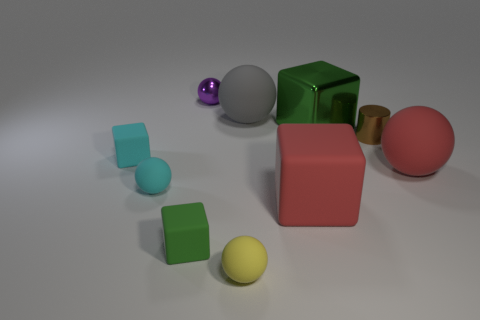Subtract all cyan blocks. How many blocks are left? 3 Subtract all green cubes. How many cubes are left? 2 Subtract all cylinders. How many objects are left? 9 Subtract 2 balls. How many balls are left? 3 Subtract all yellow balls. How many cyan cubes are left? 1 Subtract 1 cyan balls. How many objects are left? 9 Subtract all cyan spheres. Subtract all brown cubes. How many spheres are left? 4 Subtract all large green things. Subtract all metallic blocks. How many objects are left? 8 Add 3 small brown cylinders. How many small brown cylinders are left? 4 Add 9 gray metallic balls. How many gray metallic balls exist? 9 